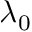<formula> <loc_0><loc_0><loc_500><loc_500>\lambda _ { 0 }</formula> 